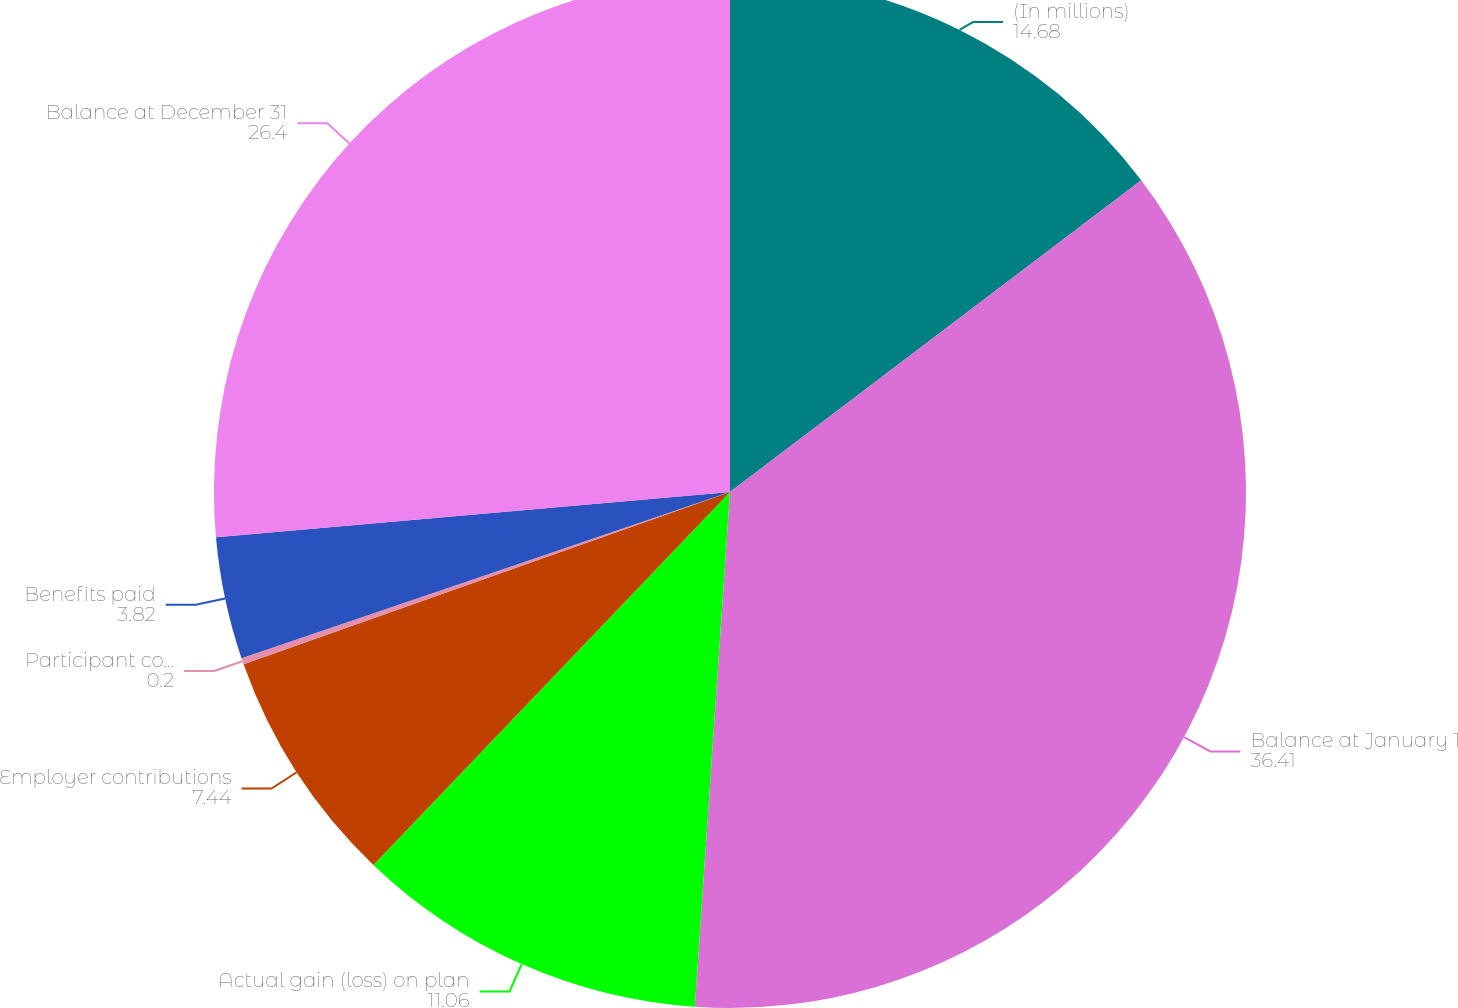<chart> <loc_0><loc_0><loc_500><loc_500><pie_chart><fcel>(In millions)<fcel>Balance at January 1<fcel>Actual gain (loss) on plan<fcel>Employer contributions<fcel>Participant contributions<fcel>Benefits paid<fcel>Balance at December 31<nl><fcel>14.68%<fcel>36.41%<fcel>11.06%<fcel>7.44%<fcel>0.2%<fcel>3.82%<fcel>26.4%<nl></chart> 